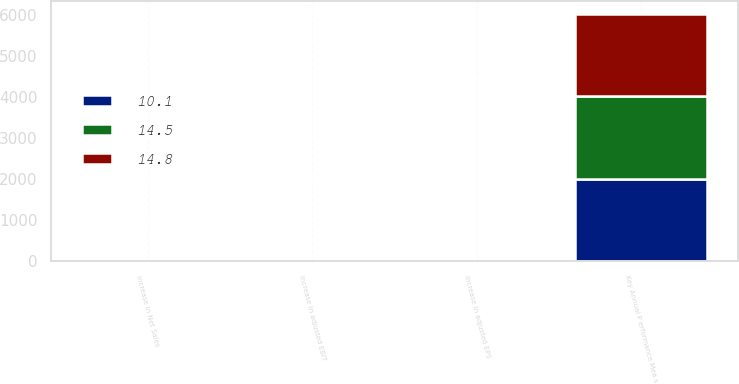Convert chart. <chart><loc_0><loc_0><loc_500><loc_500><stacked_bar_chart><ecel><fcel>Key Annual P erformance Mea s<fcel>Increase in Net Sales<fcel>Increase in adjusted EBIT<fcel>Increase in adjusted EPS<nl><fcel>14.8<fcel>2013<fcel>7.6<fcel>11.8<fcel>14.8<nl><fcel>10.1<fcel>2012<fcel>9.3<fcel>12.7<fcel>14.5<nl><fcel>14.5<fcel>2011<fcel>7.2<fcel>7.9<fcel>10.1<nl></chart> 